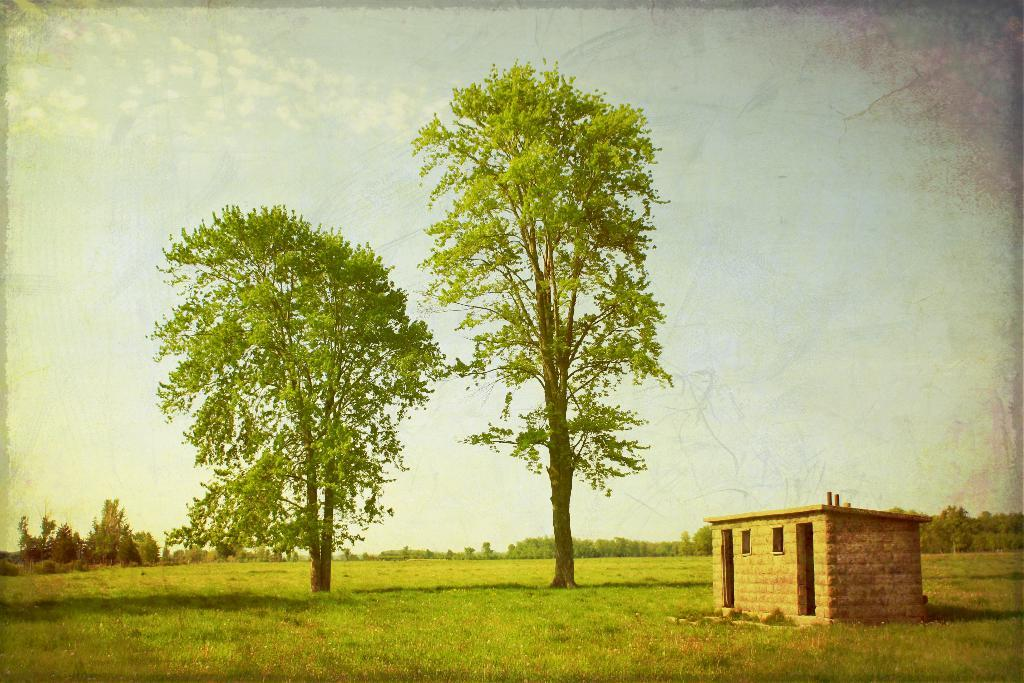What type of vegetation is present in the image? There are trees in the image. What is covering the ground in the image? There is grass on the ground in the image. Where is the house located in the image? The house is on the right side of the image. What feature of the house is mentioned in the facts? The house has windows. What can be seen in the sky in the background of the image? There are clouds in the sky in the background of the image. What type of glue is being used to hold the stone in the image? There is no glue or stone present in the image. Is the umbrella being used by anyone in the image? There is no umbrella present in the image. 